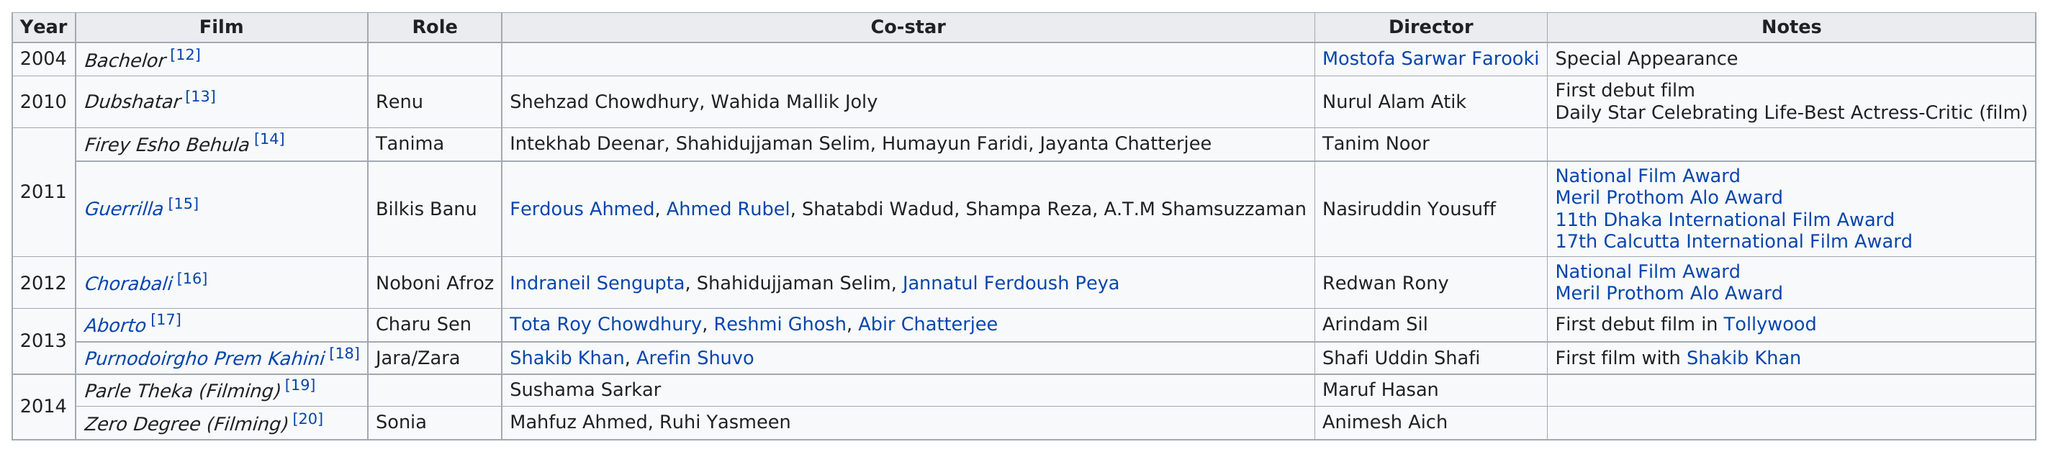Give some essential details in this illustration. Joya Ahsan played 9 movies between 2004 and 2014. The first debut film in Tollywood was 'Aborto'. The total amount of awards that the person has won from her movies since 2004 is 6. Ahsan has been in 9 movies. It is known that the last movie Joya Ahsan played in was "Zero Degree. 